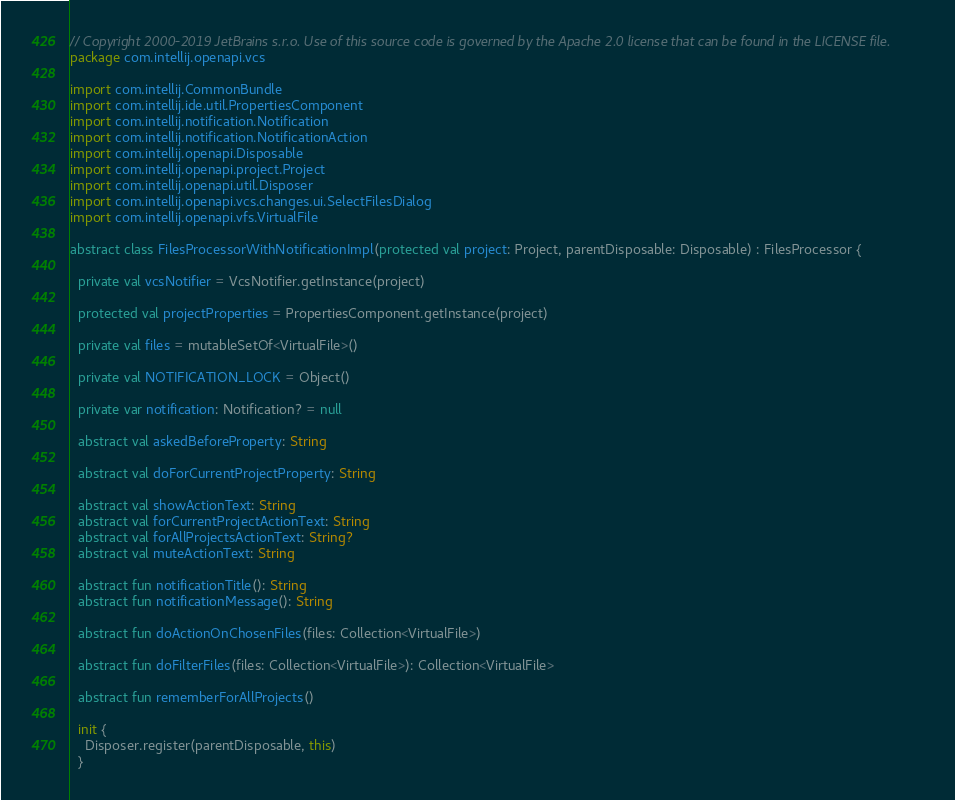Convert code to text. <code><loc_0><loc_0><loc_500><loc_500><_Kotlin_>// Copyright 2000-2019 JetBrains s.r.o. Use of this source code is governed by the Apache 2.0 license that can be found in the LICENSE file.
package com.intellij.openapi.vcs

import com.intellij.CommonBundle
import com.intellij.ide.util.PropertiesComponent
import com.intellij.notification.Notification
import com.intellij.notification.NotificationAction
import com.intellij.openapi.Disposable
import com.intellij.openapi.project.Project
import com.intellij.openapi.util.Disposer
import com.intellij.openapi.vcs.changes.ui.SelectFilesDialog
import com.intellij.openapi.vfs.VirtualFile

abstract class FilesProcessorWithNotificationImpl(protected val project: Project, parentDisposable: Disposable) : FilesProcessor {

  private val vcsNotifier = VcsNotifier.getInstance(project)

  protected val projectProperties = PropertiesComponent.getInstance(project)

  private val files = mutableSetOf<VirtualFile>()

  private val NOTIFICATION_LOCK = Object()

  private var notification: Notification? = null

  abstract val askedBeforeProperty: String

  abstract val doForCurrentProjectProperty: String

  abstract val showActionText: String
  abstract val forCurrentProjectActionText: String
  abstract val forAllProjectsActionText: String?
  abstract val muteActionText: String

  abstract fun notificationTitle(): String
  abstract fun notificationMessage(): String

  abstract fun doActionOnChosenFiles(files: Collection<VirtualFile>)

  abstract fun doFilterFiles(files: Collection<VirtualFile>): Collection<VirtualFile>

  abstract fun rememberForAllProjects()

  init {
    Disposer.register(parentDisposable, this)
  }
</code> 